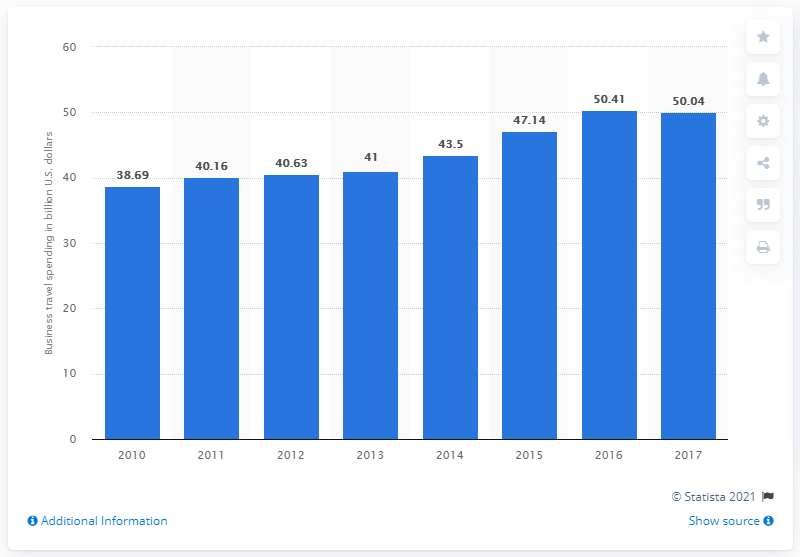Specify some key components in this picture. In 2017, the business travel spending in the United Kingdom was approximately 50.04. 